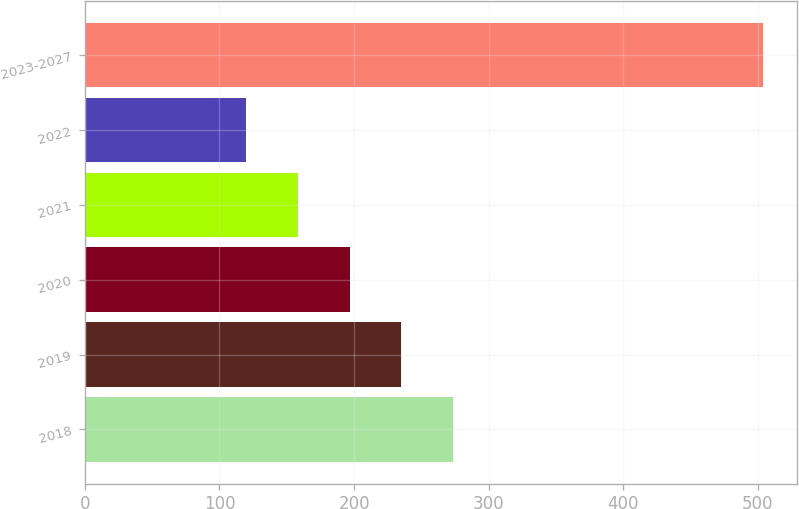Convert chart to OTSL. <chart><loc_0><loc_0><loc_500><loc_500><bar_chart><fcel>2018<fcel>2019<fcel>2020<fcel>2021<fcel>2022<fcel>2023-2027<nl><fcel>273.6<fcel>235.2<fcel>196.8<fcel>158.4<fcel>120<fcel>504<nl></chart> 